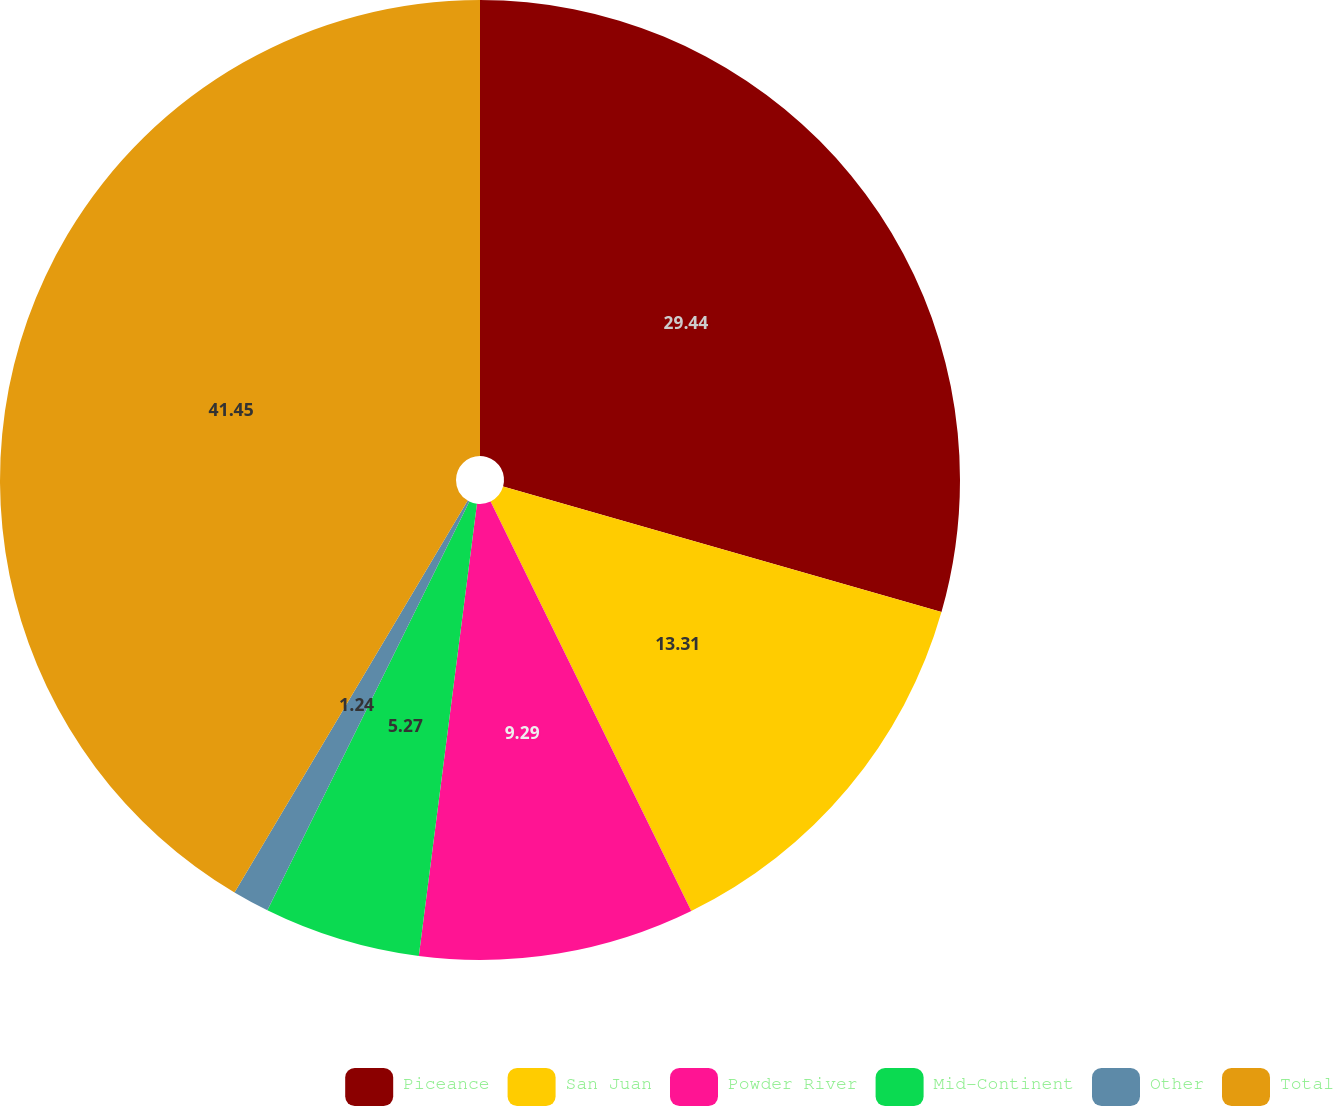Convert chart. <chart><loc_0><loc_0><loc_500><loc_500><pie_chart><fcel>Piceance<fcel>San Juan<fcel>Powder River<fcel>Mid-Continent<fcel>Other<fcel>Total<nl><fcel>29.44%<fcel>13.31%<fcel>9.29%<fcel>5.27%<fcel>1.24%<fcel>41.46%<nl></chart> 